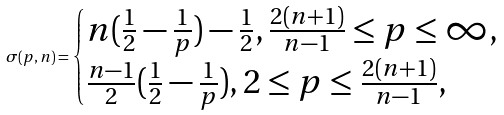Convert formula to latex. <formula><loc_0><loc_0><loc_500><loc_500>\sigma ( p , n ) = \begin{cases} n ( \frac { 1 } { 2 } - \frac { 1 } { p } ) - \frac { 1 } { 2 } , \frac { 2 ( n + 1 ) } { n - 1 } \leq p \leq \infty , \\ \frac { n - 1 } 2 ( \frac { 1 } { 2 } - \frac { 1 } { p } ) , 2 \leq p \leq \frac { 2 ( n + 1 ) } { n - 1 } , \end{cases}</formula> 